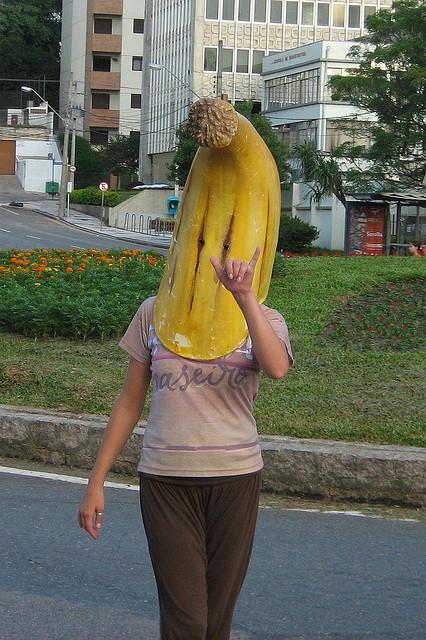What does her hand gesture mean?
Keep it brief. Peace. What fruit mask is on her head?
Give a very brief answer. Banana. What color pants is she wearing?
Give a very brief answer. Brown. 